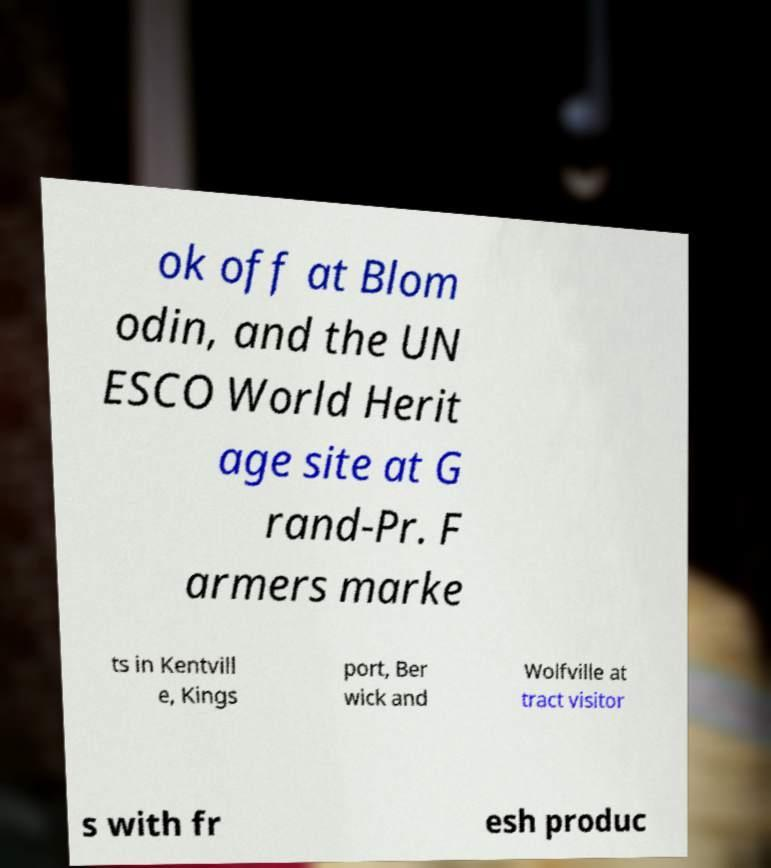Please read and relay the text visible in this image. What does it say? ok off at Blom odin, and the UN ESCO World Herit age site at G rand-Pr. F armers marke ts in Kentvill e, Kings port, Ber wick and Wolfville at tract visitor s with fr esh produc 